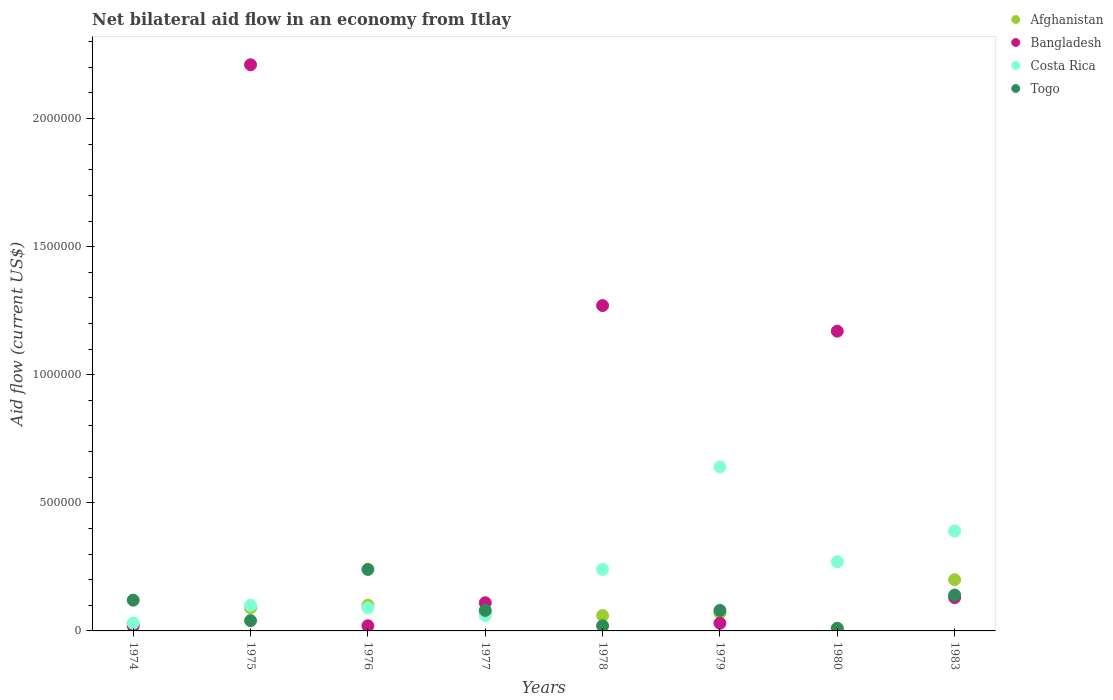How many different coloured dotlines are there?
Your answer should be very brief. 4. Is the number of dotlines equal to the number of legend labels?
Your answer should be very brief. Yes. Across all years, what is the maximum net bilateral aid flow in Bangladesh?
Your answer should be very brief. 2.21e+06. Across all years, what is the minimum net bilateral aid flow in Costa Rica?
Your answer should be very brief. 3.00e+04. In which year was the net bilateral aid flow in Togo maximum?
Your answer should be very brief. 1976. In which year was the net bilateral aid flow in Bangladesh minimum?
Provide a succinct answer. 1974. What is the total net bilateral aid flow in Bangladesh in the graph?
Your answer should be compact. 4.96e+06. What is the difference between the net bilateral aid flow in Afghanistan in 1974 and that in 1979?
Your answer should be compact. -4.00e+04. What is the average net bilateral aid flow in Costa Rica per year?
Ensure brevity in your answer.  2.28e+05. What is the ratio of the net bilateral aid flow in Togo in 1977 to that in 1979?
Offer a terse response. 1. Is the net bilateral aid flow in Togo in 1975 less than that in 1983?
Keep it short and to the point. Yes. Is the sum of the net bilateral aid flow in Bangladesh in 1976 and 1983 greater than the maximum net bilateral aid flow in Costa Rica across all years?
Keep it short and to the point. No. Is it the case that in every year, the sum of the net bilateral aid flow in Afghanistan and net bilateral aid flow in Costa Rica  is greater than the net bilateral aid flow in Togo?
Your response must be concise. No. Is the net bilateral aid flow in Afghanistan strictly greater than the net bilateral aid flow in Togo over the years?
Make the answer very short. No. What is the difference between two consecutive major ticks on the Y-axis?
Provide a short and direct response. 5.00e+05. Are the values on the major ticks of Y-axis written in scientific E-notation?
Ensure brevity in your answer.  No. Does the graph contain any zero values?
Provide a short and direct response. No. What is the title of the graph?
Provide a succinct answer. Net bilateral aid flow in an economy from Itlay. Does "Cayman Islands" appear as one of the legend labels in the graph?
Your answer should be very brief. No. What is the Aid flow (current US$) of Togo in 1974?
Your response must be concise. 1.20e+05. What is the Aid flow (current US$) in Bangladesh in 1975?
Ensure brevity in your answer.  2.21e+06. What is the Aid flow (current US$) of Togo in 1975?
Offer a very short reply. 4.00e+04. What is the Aid flow (current US$) of Bangladesh in 1976?
Keep it short and to the point. 2.00e+04. What is the Aid flow (current US$) in Togo in 1976?
Give a very brief answer. 2.40e+05. What is the Aid flow (current US$) of Afghanistan in 1977?
Keep it short and to the point. 7.00e+04. What is the Aid flow (current US$) of Bangladesh in 1977?
Ensure brevity in your answer.  1.10e+05. What is the Aid flow (current US$) of Togo in 1977?
Make the answer very short. 8.00e+04. What is the Aid flow (current US$) of Afghanistan in 1978?
Give a very brief answer. 6.00e+04. What is the Aid flow (current US$) of Bangladesh in 1978?
Your answer should be compact. 1.27e+06. What is the Aid flow (current US$) in Costa Rica in 1978?
Your answer should be very brief. 2.40e+05. What is the Aid flow (current US$) of Bangladesh in 1979?
Your answer should be compact. 3.00e+04. What is the Aid flow (current US$) of Costa Rica in 1979?
Make the answer very short. 6.40e+05. What is the Aid flow (current US$) of Togo in 1979?
Offer a terse response. 8.00e+04. What is the Aid flow (current US$) of Afghanistan in 1980?
Give a very brief answer. 10000. What is the Aid flow (current US$) in Bangladesh in 1980?
Make the answer very short. 1.17e+06. What is the Aid flow (current US$) in Togo in 1980?
Provide a succinct answer. 10000. What is the Aid flow (current US$) in Togo in 1983?
Provide a short and direct response. 1.40e+05. Across all years, what is the maximum Aid flow (current US$) of Bangladesh?
Ensure brevity in your answer.  2.21e+06. Across all years, what is the maximum Aid flow (current US$) in Costa Rica?
Your answer should be very brief. 6.40e+05. Across all years, what is the minimum Aid flow (current US$) in Afghanistan?
Make the answer very short. 10000. Across all years, what is the minimum Aid flow (current US$) in Costa Rica?
Your response must be concise. 3.00e+04. What is the total Aid flow (current US$) of Afghanistan in the graph?
Your answer should be compact. 6.30e+05. What is the total Aid flow (current US$) of Bangladesh in the graph?
Offer a terse response. 4.96e+06. What is the total Aid flow (current US$) of Costa Rica in the graph?
Offer a very short reply. 1.82e+06. What is the total Aid flow (current US$) in Togo in the graph?
Provide a short and direct response. 7.30e+05. What is the difference between the Aid flow (current US$) of Bangladesh in 1974 and that in 1975?
Provide a succinct answer. -2.19e+06. What is the difference between the Aid flow (current US$) of Costa Rica in 1974 and that in 1975?
Ensure brevity in your answer.  -7.00e+04. What is the difference between the Aid flow (current US$) in Togo in 1974 and that in 1975?
Your response must be concise. 8.00e+04. What is the difference between the Aid flow (current US$) of Bangladesh in 1974 and that in 1976?
Offer a very short reply. 0. What is the difference between the Aid flow (current US$) in Togo in 1974 and that in 1976?
Your answer should be very brief. -1.20e+05. What is the difference between the Aid flow (current US$) in Afghanistan in 1974 and that in 1977?
Ensure brevity in your answer.  -4.00e+04. What is the difference between the Aid flow (current US$) in Bangladesh in 1974 and that in 1977?
Offer a very short reply. -9.00e+04. What is the difference between the Aid flow (current US$) in Afghanistan in 1974 and that in 1978?
Offer a terse response. -3.00e+04. What is the difference between the Aid flow (current US$) in Bangladesh in 1974 and that in 1978?
Ensure brevity in your answer.  -1.25e+06. What is the difference between the Aid flow (current US$) in Afghanistan in 1974 and that in 1979?
Make the answer very short. -4.00e+04. What is the difference between the Aid flow (current US$) in Costa Rica in 1974 and that in 1979?
Ensure brevity in your answer.  -6.10e+05. What is the difference between the Aid flow (current US$) of Afghanistan in 1974 and that in 1980?
Keep it short and to the point. 2.00e+04. What is the difference between the Aid flow (current US$) in Bangladesh in 1974 and that in 1980?
Make the answer very short. -1.15e+06. What is the difference between the Aid flow (current US$) in Costa Rica in 1974 and that in 1980?
Ensure brevity in your answer.  -2.40e+05. What is the difference between the Aid flow (current US$) in Togo in 1974 and that in 1980?
Make the answer very short. 1.10e+05. What is the difference between the Aid flow (current US$) of Bangladesh in 1974 and that in 1983?
Ensure brevity in your answer.  -1.10e+05. What is the difference between the Aid flow (current US$) of Costa Rica in 1974 and that in 1983?
Offer a very short reply. -3.60e+05. What is the difference between the Aid flow (current US$) in Afghanistan in 1975 and that in 1976?
Give a very brief answer. -10000. What is the difference between the Aid flow (current US$) of Bangladesh in 1975 and that in 1976?
Ensure brevity in your answer.  2.19e+06. What is the difference between the Aid flow (current US$) in Afghanistan in 1975 and that in 1977?
Provide a short and direct response. 2.00e+04. What is the difference between the Aid flow (current US$) in Bangladesh in 1975 and that in 1977?
Your answer should be very brief. 2.10e+06. What is the difference between the Aid flow (current US$) of Togo in 1975 and that in 1977?
Make the answer very short. -4.00e+04. What is the difference between the Aid flow (current US$) in Afghanistan in 1975 and that in 1978?
Ensure brevity in your answer.  3.00e+04. What is the difference between the Aid flow (current US$) of Bangladesh in 1975 and that in 1978?
Give a very brief answer. 9.40e+05. What is the difference between the Aid flow (current US$) in Costa Rica in 1975 and that in 1978?
Offer a terse response. -1.40e+05. What is the difference between the Aid flow (current US$) in Togo in 1975 and that in 1978?
Make the answer very short. 2.00e+04. What is the difference between the Aid flow (current US$) of Bangladesh in 1975 and that in 1979?
Offer a very short reply. 2.18e+06. What is the difference between the Aid flow (current US$) in Costa Rica in 1975 and that in 1979?
Your answer should be compact. -5.40e+05. What is the difference between the Aid flow (current US$) of Afghanistan in 1975 and that in 1980?
Your answer should be compact. 8.00e+04. What is the difference between the Aid flow (current US$) in Bangladesh in 1975 and that in 1980?
Ensure brevity in your answer.  1.04e+06. What is the difference between the Aid flow (current US$) in Afghanistan in 1975 and that in 1983?
Provide a short and direct response. -1.10e+05. What is the difference between the Aid flow (current US$) of Bangladesh in 1975 and that in 1983?
Offer a very short reply. 2.08e+06. What is the difference between the Aid flow (current US$) in Costa Rica in 1975 and that in 1983?
Your response must be concise. -2.90e+05. What is the difference between the Aid flow (current US$) in Afghanistan in 1976 and that in 1977?
Provide a short and direct response. 3.00e+04. What is the difference between the Aid flow (current US$) of Bangladesh in 1976 and that in 1977?
Your answer should be very brief. -9.00e+04. What is the difference between the Aid flow (current US$) of Costa Rica in 1976 and that in 1977?
Provide a succinct answer. 3.00e+04. What is the difference between the Aid flow (current US$) of Togo in 1976 and that in 1977?
Your response must be concise. 1.60e+05. What is the difference between the Aid flow (current US$) in Bangladesh in 1976 and that in 1978?
Provide a short and direct response. -1.25e+06. What is the difference between the Aid flow (current US$) in Afghanistan in 1976 and that in 1979?
Keep it short and to the point. 3.00e+04. What is the difference between the Aid flow (current US$) in Costa Rica in 1976 and that in 1979?
Offer a terse response. -5.50e+05. What is the difference between the Aid flow (current US$) of Togo in 1976 and that in 1979?
Your answer should be very brief. 1.60e+05. What is the difference between the Aid flow (current US$) in Afghanistan in 1976 and that in 1980?
Your answer should be compact. 9.00e+04. What is the difference between the Aid flow (current US$) of Bangladesh in 1976 and that in 1980?
Your response must be concise. -1.15e+06. What is the difference between the Aid flow (current US$) of Afghanistan in 1976 and that in 1983?
Give a very brief answer. -1.00e+05. What is the difference between the Aid flow (current US$) in Togo in 1976 and that in 1983?
Keep it short and to the point. 1.00e+05. What is the difference between the Aid flow (current US$) in Bangladesh in 1977 and that in 1978?
Keep it short and to the point. -1.16e+06. What is the difference between the Aid flow (current US$) in Afghanistan in 1977 and that in 1979?
Offer a very short reply. 0. What is the difference between the Aid flow (current US$) of Bangladesh in 1977 and that in 1979?
Offer a terse response. 8.00e+04. What is the difference between the Aid flow (current US$) in Costa Rica in 1977 and that in 1979?
Your answer should be compact. -5.80e+05. What is the difference between the Aid flow (current US$) in Bangladesh in 1977 and that in 1980?
Offer a very short reply. -1.06e+06. What is the difference between the Aid flow (current US$) of Costa Rica in 1977 and that in 1980?
Your answer should be very brief. -2.10e+05. What is the difference between the Aid flow (current US$) in Togo in 1977 and that in 1980?
Ensure brevity in your answer.  7.00e+04. What is the difference between the Aid flow (current US$) in Afghanistan in 1977 and that in 1983?
Provide a short and direct response. -1.30e+05. What is the difference between the Aid flow (current US$) of Bangladesh in 1977 and that in 1983?
Your answer should be compact. -2.00e+04. What is the difference between the Aid flow (current US$) in Costa Rica in 1977 and that in 1983?
Your answer should be compact. -3.30e+05. What is the difference between the Aid flow (current US$) in Afghanistan in 1978 and that in 1979?
Ensure brevity in your answer.  -10000. What is the difference between the Aid flow (current US$) of Bangladesh in 1978 and that in 1979?
Your answer should be compact. 1.24e+06. What is the difference between the Aid flow (current US$) in Costa Rica in 1978 and that in 1979?
Provide a short and direct response. -4.00e+05. What is the difference between the Aid flow (current US$) of Bangladesh in 1978 and that in 1983?
Your response must be concise. 1.14e+06. What is the difference between the Aid flow (current US$) of Togo in 1978 and that in 1983?
Your answer should be very brief. -1.20e+05. What is the difference between the Aid flow (current US$) of Afghanistan in 1979 and that in 1980?
Your answer should be compact. 6.00e+04. What is the difference between the Aid flow (current US$) in Bangladesh in 1979 and that in 1980?
Keep it short and to the point. -1.14e+06. What is the difference between the Aid flow (current US$) in Afghanistan in 1979 and that in 1983?
Offer a terse response. -1.30e+05. What is the difference between the Aid flow (current US$) in Bangladesh in 1979 and that in 1983?
Offer a very short reply. -1.00e+05. What is the difference between the Aid flow (current US$) in Costa Rica in 1979 and that in 1983?
Your response must be concise. 2.50e+05. What is the difference between the Aid flow (current US$) of Afghanistan in 1980 and that in 1983?
Offer a terse response. -1.90e+05. What is the difference between the Aid flow (current US$) of Bangladesh in 1980 and that in 1983?
Offer a terse response. 1.04e+06. What is the difference between the Aid flow (current US$) of Togo in 1980 and that in 1983?
Make the answer very short. -1.30e+05. What is the difference between the Aid flow (current US$) of Afghanistan in 1974 and the Aid flow (current US$) of Bangladesh in 1975?
Offer a terse response. -2.18e+06. What is the difference between the Aid flow (current US$) in Afghanistan in 1974 and the Aid flow (current US$) in Costa Rica in 1975?
Your response must be concise. -7.00e+04. What is the difference between the Aid flow (current US$) in Afghanistan in 1974 and the Aid flow (current US$) in Costa Rica in 1976?
Make the answer very short. -6.00e+04. What is the difference between the Aid flow (current US$) of Afghanistan in 1974 and the Aid flow (current US$) of Togo in 1976?
Ensure brevity in your answer.  -2.10e+05. What is the difference between the Aid flow (current US$) in Bangladesh in 1974 and the Aid flow (current US$) in Costa Rica in 1976?
Offer a terse response. -7.00e+04. What is the difference between the Aid flow (current US$) of Bangladesh in 1974 and the Aid flow (current US$) of Togo in 1976?
Offer a very short reply. -2.20e+05. What is the difference between the Aid flow (current US$) in Afghanistan in 1974 and the Aid flow (current US$) in Bangladesh in 1977?
Offer a very short reply. -8.00e+04. What is the difference between the Aid flow (current US$) of Afghanistan in 1974 and the Aid flow (current US$) of Costa Rica in 1977?
Offer a very short reply. -3.00e+04. What is the difference between the Aid flow (current US$) of Afghanistan in 1974 and the Aid flow (current US$) of Togo in 1977?
Provide a succinct answer. -5.00e+04. What is the difference between the Aid flow (current US$) in Bangladesh in 1974 and the Aid flow (current US$) in Togo in 1977?
Keep it short and to the point. -6.00e+04. What is the difference between the Aid flow (current US$) of Afghanistan in 1974 and the Aid flow (current US$) of Bangladesh in 1978?
Your answer should be very brief. -1.24e+06. What is the difference between the Aid flow (current US$) in Afghanistan in 1974 and the Aid flow (current US$) in Costa Rica in 1978?
Provide a succinct answer. -2.10e+05. What is the difference between the Aid flow (current US$) of Afghanistan in 1974 and the Aid flow (current US$) of Togo in 1978?
Ensure brevity in your answer.  10000. What is the difference between the Aid flow (current US$) in Afghanistan in 1974 and the Aid flow (current US$) in Costa Rica in 1979?
Offer a terse response. -6.10e+05. What is the difference between the Aid flow (current US$) in Bangladesh in 1974 and the Aid flow (current US$) in Costa Rica in 1979?
Ensure brevity in your answer.  -6.20e+05. What is the difference between the Aid flow (current US$) of Bangladesh in 1974 and the Aid flow (current US$) of Togo in 1979?
Offer a terse response. -6.00e+04. What is the difference between the Aid flow (current US$) of Afghanistan in 1974 and the Aid flow (current US$) of Bangladesh in 1980?
Provide a succinct answer. -1.14e+06. What is the difference between the Aid flow (current US$) in Afghanistan in 1974 and the Aid flow (current US$) in Togo in 1980?
Offer a very short reply. 2.00e+04. What is the difference between the Aid flow (current US$) of Afghanistan in 1974 and the Aid flow (current US$) of Costa Rica in 1983?
Provide a succinct answer. -3.60e+05. What is the difference between the Aid flow (current US$) of Bangladesh in 1974 and the Aid flow (current US$) of Costa Rica in 1983?
Your response must be concise. -3.70e+05. What is the difference between the Aid flow (current US$) in Costa Rica in 1974 and the Aid flow (current US$) in Togo in 1983?
Keep it short and to the point. -1.10e+05. What is the difference between the Aid flow (current US$) in Afghanistan in 1975 and the Aid flow (current US$) in Togo in 1976?
Your answer should be compact. -1.50e+05. What is the difference between the Aid flow (current US$) of Bangladesh in 1975 and the Aid flow (current US$) of Costa Rica in 1976?
Offer a terse response. 2.12e+06. What is the difference between the Aid flow (current US$) in Bangladesh in 1975 and the Aid flow (current US$) in Togo in 1976?
Your response must be concise. 1.97e+06. What is the difference between the Aid flow (current US$) of Afghanistan in 1975 and the Aid flow (current US$) of Togo in 1977?
Offer a terse response. 10000. What is the difference between the Aid flow (current US$) of Bangladesh in 1975 and the Aid flow (current US$) of Costa Rica in 1977?
Provide a succinct answer. 2.15e+06. What is the difference between the Aid flow (current US$) of Bangladesh in 1975 and the Aid flow (current US$) of Togo in 1977?
Provide a succinct answer. 2.13e+06. What is the difference between the Aid flow (current US$) of Afghanistan in 1975 and the Aid flow (current US$) of Bangladesh in 1978?
Offer a very short reply. -1.18e+06. What is the difference between the Aid flow (current US$) of Afghanistan in 1975 and the Aid flow (current US$) of Costa Rica in 1978?
Your answer should be very brief. -1.50e+05. What is the difference between the Aid flow (current US$) in Bangladesh in 1975 and the Aid flow (current US$) in Costa Rica in 1978?
Ensure brevity in your answer.  1.97e+06. What is the difference between the Aid flow (current US$) in Bangladesh in 1975 and the Aid flow (current US$) in Togo in 1978?
Give a very brief answer. 2.19e+06. What is the difference between the Aid flow (current US$) in Costa Rica in 1975 and the Aid flow (current US$) in Togo in 1978?
Provide a short and direct response. 8.00e+04. What is the difference between the Aid flow (current US$) of Afghanistan in 1975 and the Aid flow (current US$) of Bangladesh in 1979?
Make the answer very short. 6.00e+04. What is the difference between the Aid flow (current US$) in Afghanistan in 1975 and the Aid flow (current US$) in Costa Rica in 1979?
Offer a very short reply. -5.50e+05. What is the difference between the Aid flow (current US$) of Bangladesh in 1975 and the Aid flow (current US$) of Costa Rica in 1979?
Your response must be concise. 1.57e+06. What is the difference between the Aid flow (current US$) of Bangladesh in 1975 and the Aid flow (current US$) of Togo in 1979?
Offer a very short reply. 2.13e+06. What is the difference between the Aid flow (current US$) in Afghanistan in 1975 and the Aid flow (current US$) in Bangladesh in 1980?
Your answer should be very brief. -1.08e+06. What is the difference between the Aid flow (current US$) of Bangladesh in 1975 and the Aid flow (current US$) of Costa Rica in 1980?
Provide a succinct answer. 1.94e+06. What is the difference between the Aid flow (current US$) of Bangladesh in 1975 and the Aid flow (current US$) of Togo in 1980?
Offer a very short reply. 2.20e+06. What is the difference between the Aid flow (current US$) of Costa Rica in 1975 and the Aid flow (current US$) of Togo in 1980?
Your answer should be compact. 9.00e+04. What is the difference between the Aid flow (current US$) of Afghanistan in 1975 and the Aid flow (current US$) of Costa Rica in 1983?
Give a very brief answer. -3.00e+05. What is the difference between the Aid flow (current US$) of Afghanistan in 1975 and the Aid flow (current US$) of Togo in 1983?
Give a very brief answer. -5.00e+04. What is the difference between the Aid flow (current US$) in Bangladesh in 1975 and the Aid flow (current US$) in Costa Rica in 1983?
Keep it short and to the point. 1.82e+06. What is the difference between the Aid flow (current US$) of Bangladesh in 1975 and the Aid flow (current US$) of Togo in 1983?
Provide a short and direct response. 2.07e+06. What is the difference between the Aid flow (current US$) in Afghanistan in 1976 and the Aid flow (current US$) in Bangladesh in 1977?
Keep it short and to the point. -10000. What is the difference between the Aid flow (current US$) in Afghanistan in 1976 and the Aid flow (current US$) in Costa Rica in 1977?
Give a very brief answer. 4.00e+04. What is the difference between the Aid flow (current US$) of Afghanistan in 1976 and the Aid flow (current US$) of Togo in 1977?
Provide a succinct answer. 2.00e+04. What is the difference between the Aid flow (current US$) of Bangladesh in 1976 and the Aid flow (current US$) of Togo in 1977?
Offer a terse response. -6.00e+04. What is the difference between the Aid flow (current US$) in Afghanistan in 1976 and the Aid flow (current US$) in Bangladesh in 1978?
Give a very brief answer. -1.17e+06. What is the difference between the Aid flow (current US$) in Bangladesh in 1976 and the Aid flow (current US$) in Costa Rica in 1978?
Give a very brief answer. -2.20e+05. What is the difference between the Aid flow (current US$) of Bangladesh in 1976 and the Aid flow (current US$) of Togo in 1978?
Provide a succinct answer. 0. What is the difference between the Aid flow (current US$) of Afghanistan in 1976 and the Aid flow (current US$) of Bangladesh in 1979?
Ensure brevity in your answer.  7.00e+04. What is the difference between the Aid flow (current US$) in Afghanistan in 1976 and the Aid flow (current US$) in Costa Rica in 1979?
Your response must be concise. -5.40e+05. What is the difference between the Aid flow (current US$) in Afghanistan in 1976 and the Aid flow (current US$) in Togo in 1979?
Your response must be concise. 2.00e+04. What is the difference between the Aid flow (current US$) in Bangladesh in 1976 and the Aid flow (current US$) in Costa Rica in 1979?
Offer a very short reply. -6.20e+05. What is the difference between the Aid flow (current US$) of Afghanistan in 1976 and the Aid flow (current US$) of Bangladesh in 1980?
Offer a terse response. -1.07e+06. What is the difference between the Aid flow (current US$) of Afghanistan in 1976 and the Aid flow (current US$) of Costa Rica in 1980?
Give a very brief answer. -1.70e+05. What is the difference between the Aid flow (current US$) of Bangladesh in 1976 and the Aid flow (current US$) of Costa Rica in 1980?
Give a very brief answer. -2.50e+05. What is the difference between the Aid flow (current US$) in Afghanistan in 1976 and the Aid flow (current US$) in Bangladesh in 1983?
Your response must be concise. -3.00e+04. What is the difference between the Aid flow (current US$) in Bangladesh in 1976 and the Aid flow (current US$) in Costa Rica in 1983?
Your answer should be compact. -3.70e+05. What is the difference between the Aid flow (current US$) of Bangladesh in 1976 and the Aid flow (current US$) of Togo in 1983?
Your answer should be very brief. -1.20e+05. What is the difference between the Aid flow (current US$) in Afghanistan in 1977 and the Aid flow (current US$) in Bangladesh in 1978?
Your response must be concise. -1.20e+06. What is the difference between the Aid flow (current US$) of Costa Rica in 1977 and the Aid flow (current US$) of Togo in 1978?
Make the answer very short. 4.00e+04. What is the difference between the Aid flow (current US$) of Afghanistan in 1977 and the Aid flow (current US$) of Bangladesh in 1979?
Ensure brevity in your answer.  4.00e+04. What is the difference between the Aid flow (current US$) of Afghanistan in 1977 and the Aid flow (current US$) of Costa Rica in 1979?
Your answer should be compact. -5.70e+05. What is the difference between the Aid flow (current US$) in Bangladesh in 1977 and the Aid flow (current US$) in Costa Rica in 1979?
Offer a very short reply. -5.30e+05. What is the difference between the Aid flow (current US$) of Bangladesh in 1977 and the Aid flow (current US$) of Togo in 1979?
Offer a terse response. 3.00e+04. What is the difference between the Aid flow (current US$) in Costa Rica in 1977 and the Aid flow (current US$) in Togo in 1979?
Your answer should be compact. -2.00e+04. What is the difference between the Aid flow (current US$) of Afghanistan in 1977 and the Aid flow (current US$) of Bangladesh in 1980?
Ensure brevity in your answer.  -1.10e+06. What is the difference between the Aid flow (current US$) of Afghanistan in 1977 and the Aid flow (current US$) of Togo in 1980?
Provide a short and direct response. 6.00e+04. What is the difference between the Aid flow (current US$) of Bangladesh in 1977 and the Aid flow (current US$) of Costa Rica in 1980?
Keep it short and to the point. -1.60e+05. What is the difference between the Aid flow (current US$) of Costa Rica in 1977 and the Aid flow (current US$) of Togo in 1980?
Your answer should be very brief. 5.00e+04. What is the difference between the Aid flow (current US$) in Afghanistan in 1977 and the Aid flow (current US$) in Bangladesh in 1983?
Offer a terse response. -6.00e+04. What is the difference between the Aid flow (current US$) of Afghanistan in 1977 and the Aid flow (current US$) of Costa Rica in 1983?
Offer a terse response. -3.20e+05. What is the difference between the Aid flow (current US$) in Afghanistan in 1977 and the Aid flow (current US$) in Togo in 1983?
Your response must be concise. -7.00e+04. What is the difference between the Aid flow (current US$) of Bangladesh in 1977 and the Aid flow (current US$) of Costa Rica in 1983?
Offer a very short reply. -2.80e+05. What is the difference between the Aid flow (current US$) in Bangladesh in 1977 and the Aid flow (current US$) in Togo in 1983?
Offer a very short reply. -3.00e+04. What is the difference between the Aid flow (current US$) in Afghanistan in 1978 and the Aid flow (current US$) in Bangladesh in 1979?
Provide a short and direct response. 3.00e+04. What is the difference between the Aid flow (current US$) of Afghanistan in 1978 and the Aid flow (current US$) of Costa Rica in 1979?
Offer a terse response. -5.80e+05. What is the difference between the Aid flow (current US$) in Afghanistan in 1978 and the Aid flow (current US$) in Togo in 1979?
Offer a very short reply. -2.00e+04. What is the difference between the Aid flow (current US$) of Bangladesh in 1978 and the Aid flow (current US$) of Costa Rica in 1979?
Provide a short and direct response. 6.30e+05. What is the difference between the Aid flow (current US$) of Bangladesh in 1978 and the Aid flow (current US$) of Togo in 1979?
Ensure brevity in your answer.  1.19e+06. What is the difference between the Aid flow (current US$) in Afghanistan in 1978 and the Aid flow (current US$) in Bangladesh in 1980?
Provide a short and direct response. -1.11e+06. What is the difference between the Aid flow (current US$) in Afghanistan in 1978 and the Aid flow (current US$) in Costa Rica in 1980?
Offer a terse response. -2.10e+05. What is the difference between the Aid flow (current US$) in Bangladesh in 1978 and the Aid flow (current US$) in Costa Rica in 1980?
Provide a short and direct response. 1.00e+06. What is the difference between the Aid flow (current US$) in Bangladesh in 1978 and the Aid flow (current US$) in Togo in 1980?
Ensure brevity in your answer.  1.26e+06. What is the difference between the Aid flow (current US$) of Costa Rica in 1978 and the Aid flow (current US$) of Togo in 1980?
Provide a succinct answer. 2.30e+05. What is the difference between the Aid flow (current US$) of Afghanistan in 1978 and the Aid flow (current US$) of Bangladesh in 1983?
Offer a very short reply. -7.00e+04. What is the difference between the Aid flow (current US$) of Afghanistan in 1978 and the Aid flow (current US$) of Costa Rica in 1983?
Provide a short and direct response. -3.30e+05. What is the difference between the Aid flow (current US$) in Bangladesh in 1978 and the Aid flow (current US$) in Costa Rica in 1983?
Provide a succinct answer. 8.80e+05. What is the difference between the Aid flow (current US$) of Bangladesh in 1978 and the Aid flow (current US$) of Togo in 1983?
Your answer should be very brief. 1.13e+06. What is the difference between the Aid flow (current US$) in Costa Rica in 1978 and the Aid flow (current US$) in Togo in 1983?
Provide a short and direct response. 1.00e+05. What is the difference between the Aid flow (current US$) of Afghanistan in 1979 and the Aid flow (current US$) of Bangladesh in 1980?
Give a very brief answer. -1.10e+06. What is the difference between the Aid flow (current US$) of Afghanistan in 1979 and the Aid flow (current US$) of Costa Rica in 1980?
Provide a succinct answer. -2.00e+05. What is the difference between the Aid flow (current US$) of Afghanistan in 1979 and the Aid flow (current US$) of Togo in 1980?
Provide a short and direct response. 6.00e+04. What is the difference between the Aid flow (current US$) in Bangladesh in 1979 and the Aid flow (current US$) in Togo in 1980?
Keep it short and to the point. 2.00e+04. What is the difference between the Aid flow (current US$) in Costa Rica in 1979 and the Aid flow (current US$) in Togo in 1980?
Ensure brevity in your answer.  6.30e+05. What is the difference between the Aid flow (current US$) of Afghanistan in 1979 and the Aid flow (current US$) of Bangladesh in 1983?
Make the answer very short. -6.00e+04. What is the difference between the Aid flow (current US$) in Afghanistan in 1979 and the Aid flow (current US$) in Costa Rica in 1983?
Your answer should be very brief. -3.20e+05. What is the difference between the Aid flow (current US$) in Bangladesh in 1979 and the Aid flow (current US$) in Costa Rica in 1983?
Your answer should be very brief. -3.60e+05. What is the difference between the Aid flow (current US$) of Costa Rica in 1979 and the Aid flow (current US$) of Togo in 1983?
Your answer should be compact. 5.00e+05. What is the difference between the Aid flow (current US$) in Afghanistan in 1980 and the Aid flow (current US$) in Bangladesh in 1983?
Make the answer very short. -1.20e+05. What is the difference between the Aid flow (current US$) of Afghanistan in 1980 and the Aid flow (current US$) of Costa Rica in 1983?
Your answer should be very brief. -3.80e+05. What is the difference between the Aid flow (current US$) of Afghanistan in 1980 and the Aid flow (current US$) of Togo in 1983?
Your response must be concise. -1.30e+05. What is the difference between the Aid flow (current US$) of Bangladesh in 1980 and the Aid flow (current US$) of Costa Rica in 1983?
Make the answer very short. 7.80e+05. What is the difference between the Aid flow (current US$) in Bangladesh in 1980 and the Aid flow (current US$) in Togo in 1983?
Your answer should be very brief. 1.03e+06. What is the difference between the Aid flow (current US$) of Costa Rica in 1980 and the Aid flow (current US$) of Togo in 1983?
Your answer should be compact. 1.30e+05. What is the average Aid flow (current US$) of Afghanistan per year?
Keep it short and to the point. 7.88e+04. What is the average Aid flow (current US$) in Bangladesh per year?
Your response must be concise. 6.20e+05. What is the average Aid flow (current US$) in Costa Rica per year?
Make the answer very short. 2.28e+05. What is the average Aid flow (current US$) in Togo per year?
Offer a terse response. 9.12e+04. In the year 1974, what is the difference between the Aid flow (current US$) of Afghanistan and Aid flow (current US$) of Togo?
Your answer should be compact. -9.00e+04. In the year 1974, what is the difference between the Aid flow (current US$) in Bangladesh and Aid flow (current US$) in Costa Rica?
Give a very brief answer. -10000. In the year 1975, what is the difference between the Aid flow (current US$) of Afghanistan and Aid flow (current US$) of Bangladesh?
Offer a very short reply. -2.12e+06. In the year 1975, what is the difference between the Aid flow (current US$) of Afghanistan and Aid flow (current US$) of Costa Rica?
Ensure brevity in your answer.  -10000. In the year 1975, what is the difference between the Aid flow (current US$) in Bangladesh and Aid flow (current US$) in Costa Rica?
Your response must be concise. 2.11e+06. In the year 1975, what is the difference between the Aid flow (current US$) of Bangladesh and Aid flow (current US$) of Togo?
Make the answer very short. 2.17e+06. In the year 1976, what is the difference between the Aid flow (current US$) in Afghanistan and Aid flow (current US$) in Costa Rica?
Offer a terse response. 10000. In the year 1976, what is the difference between the Aid flow (current US$) in Bangladesh and Aid flow (current US$) in Togo?
Offer a very short reply. -2.20e+05. In the year 1977, what is the difference between the Aid flow (current US$) in Afghanistan and Aid flow (current US$) in Bangladesh?
Make the answer very short. -4.00e+04. In the year 1977, what is the difference between the Aid flow (current US$) of Afghanistan and Aid flow (current US$) of Togo?
Your answer should be very brief. -10000. In the year 1978, what is the difference between the Aid flow (current US$) in Afghanistan and Aid flow (current US$) in Bangladesh?
Give a very brief answer. -1.21e+06. In the year 1978, what is the difference between the Aid flow (current US$) in Bangladesh and Aid flow (current US$) in Costa Rica?
Provide a succinct answer. 1.03e+06. In the year 1978, what is the difference between the Aid flow (current US$) in Bangladesh and Aid flow (current US$) in Togo?
Your answer should be very brief. 1.25e+06. In the year 1979, what is the difference between the Aid flow (current US$) in Afghanistan and Aid flow (current US$) in Costa Rica?
Offer a terse response. -5.70e+05. In the year 1979, what is the difference between the Aid flow (current US$) of Bangladesh and Aid flow (current US$) of Costa Rica?
Offer a terse response. -6.10e+05. In the year 1979, what is the difference between the Aid flow (current US$) of Costa Rica and Aid flow (current US$) of Togo?
Provide a succinct answer. 5.60e+05. In the year 1980, what is the difference between the Aid flow (current US$) in Afghanistan and Aid flow (current US$) in Bangladesh?
Offer a terse response. -1.16e+06. In the year 1980, what is the difference between the Aid flow (current US$) of Bangladesh and Aid flow (current US$) of Costa Rica?
Your response must be concise. 9.00e+05. In the year 1980, what is the difference between the Aid flow (current US$) in Bangladesh and Aid flow (current US$) in Togo?
Your answer should be compact. 1.16e+06. In the year 1983, what is the difference between the Aid flow (current US$) of Afghanistan and Aid flow (current US$) of Costa Rica?
Make the answer very short. -1.90e+05. In the year 1983, what is the difference between the Aid flow (current US$) in Bangladesh and Aid flow (current US$) in Costa Rica?
Your answer should be very brief. -2.60e+05. In the year 1983, what is the difference between the Aid flow (current US$) of Bangladesh and Aid flow (current US$) of Togo?
Ensure brevity in your answer.  -10000. What is the ratio of the Aid flow (current US$) of Bangladesh in 1974 to that in 1975?
Give a very brief answer. 0.01. What is the ratio of the Aid flow (current US$) of Togo in 1974 to that in 1975?
Your answer should be compact. 3. What is the ratio of the Aid flow (current US$) in Afghanistan in 1974 to that in 1976?
Provide a succinct answer. 0.3. What is the ratio of the Aid flow (current US$) of Costa Rica in 1974 to that in 1976?
Your answer should be very brief. 0.33. What is the ratio of the Aid flow (current US$) in Afghanistan in 1974 to that in 1977?
Provide a short and direct response. 0.43. What is the ratio of the Aid flow (current US$) of Bangladesh in 1974 to that in 1977?
Keep it short and to the point. 0.18. What is the ratio of the Aid flow (current US$) of Togo in 1974 to that in 1977?
Make the answer very short. 1.5. What is the ratio of the Aid flow (current US$) of Bangladesh in 1974 to that in 1978?
Make the answer very short. 0.02. What is the ratio of the Aid flow (current US$) of Togo in 1974 to that in 1978?
Ensure brevity in your answer.  6. What is the ratio of the Aid flow (current US$) in Afghanistan in 1974 to that in 1979?
Offer a terse response. 0.43. What is the ratio of the Aid flow (current US$) in Bangladesh in 1974 to that in 1979?
Offer a very short reply. 0.67. What is the ratio of the Aid flow (current US$) in Costa Rica in 1974 to that in 1979?
Your answer should be compact. 0.05. What is the ratio of the Aid flow (current US$) of Afghanistan in 1974 to that in 1980?
Ensure brevity in your answer.  3. What is the ratio of the Aid flow (current US$) in Bangladesh in 1974 to that in 1980?
Keep it short and to the point. 0.02. What is the ratio of the Aid flow (current US$) of Afghanistan in 1974 to that in 1983?
Provide a succinct answer. 0.15. What is the ratio of the Aid flow (current US$) of Bangladesh in 1974 to that in 1983?
Give a very brief answer. 0.15. What is the ratio of the Aid flow (current US$) in Costa Rica in 1974 to that in 1983?
Offer a terse response. 0.08. What is the ratio of the Aid flow (current US$) in Togo in 1974 to that in 1983?
Ensure brevity in your answer.  0.86. What is the ratio of the Aid flow (current US$) in Bangladesh in 1975 to that in 1976?
Ensure brevity in your answer.  110.5. What is the ratio of the Aid flow (current US$) of Afghanistan in 1975 to that in 1977?
Your response must be concise. 1.29. What is the ratio of the Aid flow (current US$) of Bangladesh in 1975 to that in 1977?
Offer a very short reply. 20.09. What is the ratio of the Aid flow (current US$) in Costa Rica in 1975 to that in 1977?
Your answer should be very brief. 1.67. What is the ratio of the Aid flow (current US$) in Afghanistan in 1975 to that in 1978?
Your answer should be compact. 1.5. What is the ratio of the Aid flow (current US$) in Bangladesh in 1975 to that in 1978?
Your answer should be very brief. 1.74. What is the ratio of the Aid flow (current US$) in Costa Rica in 1975 to that in 1978?
Give a very brief answer. 0.42. What is the ratio of the Aid flow (current US$) in Togo in 1975 to that in 1978?
Give a very brief answer. 2. What is the ratio of the Aid flow (current US$) of Bangladesh in 1975 to that in 1979?
Your response must be concise. 73.67. What is the ratio of the Aid flow (current US$) of Costa Rica in 1975 to that in 1979?
Offer a very short reply. 0.16. What is the ratio of the Aid flow (current US$) in Afghanistan in 1975 to that in 1980?
Your answer should be compact. 9. What is the ratio of the Aid flow (current US$) in Bangladesh in 1975 to that in 1980?
Keep it short and to the point. 1.89. What is the ratio of the Aid flow (current US$) in Costa Rica in 1975 to that in 1980?
Your answer should be compact. 0.37. What is the ratio of the Aid flow (current US$) of Afghanistan in 1975 to that in 1983?
Provide a succinct answer. 0.45. What is the ratio of the Aid flow (current US$) in Bangladesh in 1975 to that in 1983?
Provide a succinct answer. 17. What is the ratio of the Aid flow (current US$) of Costa Rica in 1975 to that in 1983?
Your answer should be compact. 0.26. What is the ratio of the Aid flow (current US$) of Togo in 1975 to that in 1983?
Your response must be concise. 0.29. What is the ratio of the Aid flow (current US$) in Afghanistan in 1976 to that in 1977?
Your answer should be very brief. 1.43. What is the ratio of the Aid flow (current US$) of Bangladesh in 1976 to that in 1977?
Offer a terse response. 0.18. What is the ratio of the Aid flow (current US$) of Costa Rica in 1976 to that in 1977?
Offer a very short reply. 1.5. What is the ratio of the Aid flow (current US$) in Togo in 1976 to that in 1977?
Ensure brevity in your answer.  3. What is the ratio of the Aid flow (current US$) of Afghanistan in 1976 to that in 1978?
Your answer should be compact. 1.67. What is the ratio of the Aid flow (current US$) of Bangladesh in 1976 to that in 1978?
Your answer should be very brief. 0.02. What is the ratio of the Aid flow (current US$) in Afghanistan in 1976 to that in 1979?
Keep it short and to the point. 1.43. What is the ratio of the Aid flow (current US$) of Bangladesh in 1976 to that in 1979?
Keep it short and to the point. 0.67. What is the ratio of the Aid flow (current US$) of Costa Rica in 1976 to that in 1979?
Provide a succinct answer. 0.14. What is the ratio of the Aid flow (current US$) of Afghanistan in 1976 to that in 1980?
Provide a succinct answer. 10. What is the ratio of the Aid flow (current US$) of Bangladesh in 1976 to that in 1980?
Offer a very short reply. 0.02. What is the ratio of the Aid flow (current US$) of Costa Rica in 1976 to that in 1980?
Keep it short and to the point. 0.33. What is the ratio of the Aid flow (current US$) of Togo in 1976 to that in 1980?
Provide a succinct answer. 24. What is the ratio of the Aid flow (current US$) in Bangladesh in 1976 to that in 1983?
Provide a short and direct response. 0.15. What is the ratio of the Aid flow (current US$) in Costa Rica in 1976 to that in 1983?
Offer a very short reply. 0.23. What is the ratio of the Aid flow (current US$) in Togo in 1976 to that in 1983?
Give a very brief answer. 1.71. What is the ratio of the Aid flow (current US$) of Bangladesh in 1977 to that in 1978?
Make the answer very short. 0.09. What is the ratio of the Aid flow (current US$) of Costa Rica in 1977 to that in 1978?
Ensure brevity in your answer.  0.25. What is the ratio of the Aid flow (current US$) of Togo in 1977 to that in 1978?
Make the answer very short. 4. What is the ratio of the Aid flow (current US$) in Bangladesh in 1977 to that in 1979?
Your answer should be compact. 3.67. What is the ratio of the Aid flow (current US$) of Costa Rica in 1977 to that in 1979?
Your answer should be compact. 0.09. What is the ratio of the Aid flow (current US$) of Togo in 1977 to that in 1979?
Your response must be concise. 1. What is the ratio of the Aid flow (current US$) of Afghanistan in 1977 to that in 1980?
Your answer should be compact. 7. What is the ratio of the Aid flow (current US$) in Bangladesh in 1977 to that in 1980?
Offer a terse response. 0.09. What is the ratio of the Aid flow (current US$) in Costa Rica in 1977 to that in 1980?
Keep it short and to the point. 0.22. What is the ratio of the Aid flow (current US$) of Togo in 1977 to that in 1980?
Give a very brief answer. 8. What is the ratio of the Aid flow (current US$) of Afghanistan in 1977 to that in 1983?
Offer a terse response. 0.35. What is the ratio of the Aid flow (current US$) of Bangladesh in 1977 to that in 1983?
Your answer should be very brief. 0.85. What is the ratio of the Aid flow (current US$) in Costa Rica in 1977 to that in 1983?
Provide a succinct answer. 0.15. What is the ratio of the Aid flow (current US$) of Togo in 1977 to that in 1983?
Offer a terse response. 0.57. What is the ratio of the Aid flow (current US$) of Afghanistan in 1978 to that in 1979?
Your answer should be compact. 0.86. What is the ratio of the Aid flow (current US$) in Bangladesh in 1978 to that in 1979?
Offer a very short reply. 42.33. What is the ratio of the Aid flow (current US$) in Costa Rica in 1978 to that in 1979?
Offer a terse response. 0.38. What is the ratio of the Aid flow (current US$) of Togo in 1978 to that in 1979?
Keep it short and to the point. 0.25. What is the ratio of the Aid flow (current US$) in Afghanistan in 1978 to that in 1980?
Make the answer very short. 6. What is the ratio of the Aid flow (current US$) in Bangladesh in 1978 to that in 1980?
Make the answer very short. 1.09. What is the ratio of the Aid flow (current US$) of Afghanistan in 1978 to that in 1983?
Your answer should be compact. 0.3. What is the ratio of the Aid flow (current US$) of Bangladesh in 1978 to that in 1983?
Your response must be concise. 9.77. What is the ratio of the Aid flow (current US$) of Costa Rica in 1978 to that in 1983?
Offer a terse response. 0.62. What is the ratio of the Aid flow (current US$) in Togo in 1978 to that in 1983?
Your answer should be very brief. 0.14. What is the ratio of the Aid flow (current US$) in Afghanistan in 1979 to that in 1980?
Keep it short and to the point. 7. What is the ratio of the Aid flow (current US$) in Bangladesh in 1979 to that in 1980?
Offer a very short reply. 0.03. What is the ratio of the Aid flow (current US$) in Costa Rica in 1979 to that in 1980?
Offer a terse response. 2.37. What is the ratio of the Aid flow (current US$) of Togo in 1979 to that in 1980?
Give a very brief answer. 8. What is the ratio of the Aid flow (current US$) in Bangladesh in 1979 to that in 1983?
Offer a terse response. 0.23. What is the ratio of the Aid flow (current US$) of Costa Rica in 1979 to that in 1983?
Your answer should be compact. 1.64. What is the ratio of the Aid flow (current US$) of Togo in 1979 to that in 1983?
Ensure brevity in your answer.  0.57. What is the ratio of the Aid flow (current US$) in Costa Rica in 1980 to that in 1983?
Give a very brief answer. 0.69. What is the ratio of the Aid flow (current US$) in Togo in 1980 to that in 1983?
Keep it short and to the point. 0.07. What is the difference between the highest and the second highest Aid flow (current US$) in Afghanistan?
Provide a short and direct response. 1.00e+05. What is the difference between the highest and the second highest Aid flow (current US$) in Bangladesh?
Provide a short and direct response. 9.40e+05. What is the difference between the highest and the second highest Aid flow (current US$) of Costa Rica?
Offer a very short reply. 2.50e+05. What is the difference between the highest and the second highest Aid flow (current US$) of Togo?
Provide a short and direct response. 1.00e+05. What is the difference between the highest and the lowest Aid flow (current US$) of Bangladesh?
Make the answer very short. 2.19e+06. What is the difference between the highest and the lowest Aid flow (current US$) in Costa Rica?
Your answer should be very brief. 6.10e+05. 